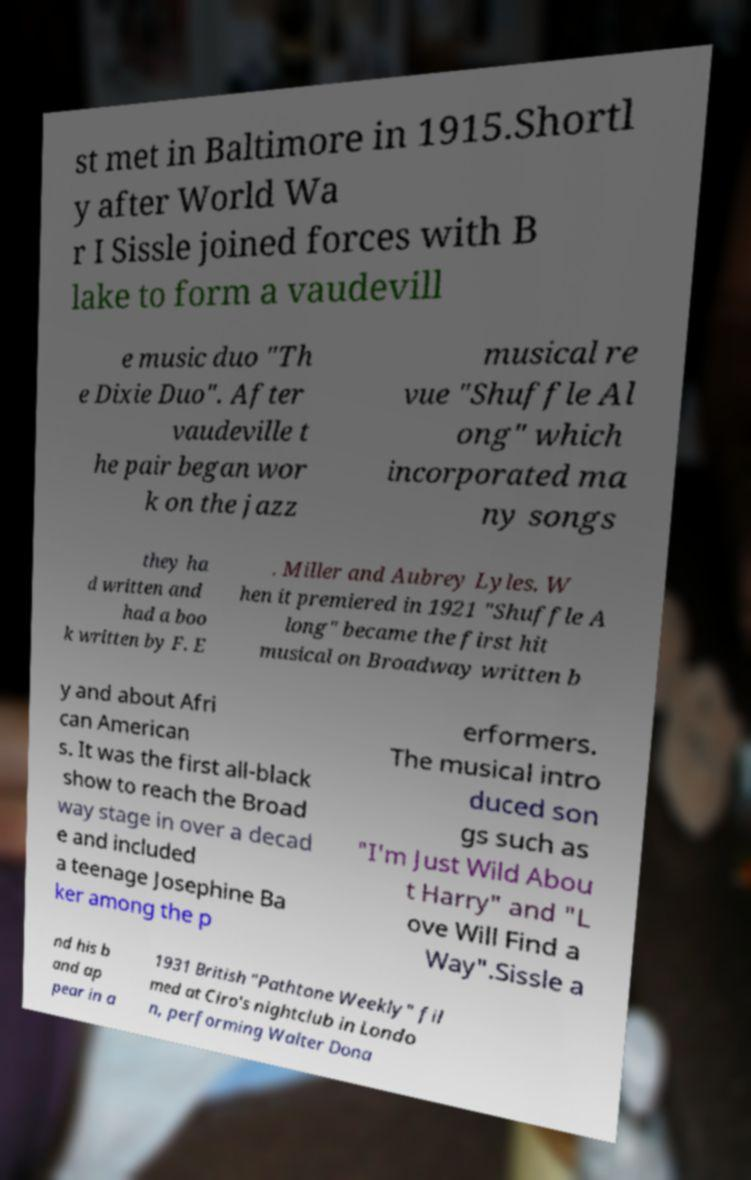What messages or text are displayed in this image? I need them in a readable, typed format. st met in Baltimore in 1915.Shortl y after World Wa r I Sissle joined forces with B lake to form a vaudevill e music duo "Th e Dixie Duo". After vaudeville t he pair began wor k on the jazz musical re vue "Shuffle Al ong" which incorporated ma ny songs they ha d written and had a boo k written by F. E . Miller and Aubrey Lyles. W hen it premiered in 1921 "Shuffle A long" became the first hit musical on Broadway written b y and about Afri can American s. It was the first all-black show to reach the Broad way stage in over a decad e and included a teenage Josephine Ba ker among the p erformers. The musical intro duced son gs such as "I'm Just Wild Abou t Harry" and "L ove Will Find a Way".Sissle a nd his b and ap pear in a 1931 British "Pathtone Weekly" fil med at Ciro's nightclub in Londo n, performing Walter Dona 